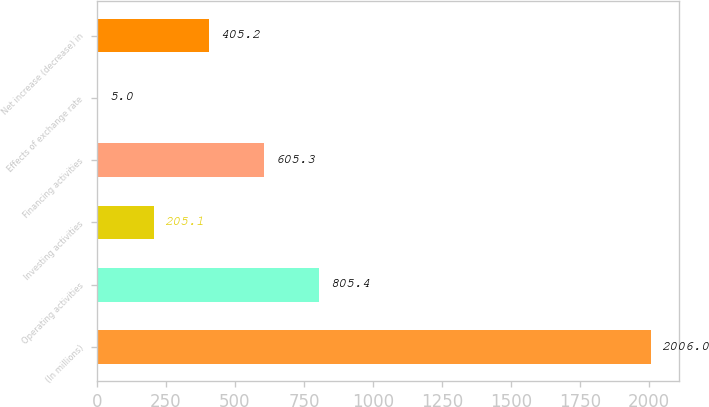Convert chart. <chart><loc_0><loc_0><loc_500><loc_500><bar_chart><fcel>(In millions)<fcel>Operating activities<fcel>Investing activities<fcel>Financing activities<fcel>Effects of exchange rate<fcel>Net increase (decrease) in<nl><fcel>2006<fcel>805.4<fcel>205.1<fcel>605.3<fcel>5<fcel>405.2<nl></chart> 